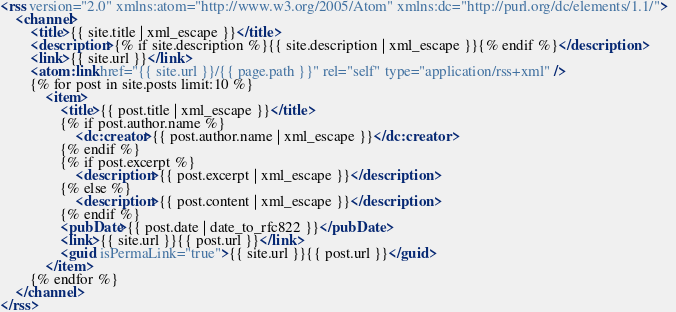Convert code to text. <code><loc_0><loc_0><loc_500><loc_500><_XML_><rss version="2.0" xmlns:atom="http://www.w3.org/2005/Atom" xmlns:dc="http://purl.org/dc/elements/1.1/">
	<channel>
		<title>{{ site.title | xml_escape }}</title>
		<description>{% if site.description %}{{ site.description | xml_escape }}{% endif %}</description>		
		<link>{{ site.url }}</link>
		<atom:link href="{{ site.url }}/{{ page.path }}" rel="self" type="application/rss+xml" />
		{% for post in site.posts limit:10 %}
			<item>
				<title>{{ post.title | xml_escape }}</title>
				{% if post.author.name %}
					<dc:creator>{{ post.author.name | xml_escape }}</dc:creator>
				{% endif %}        
				{% if post.excerpt %}
					<description>{{ post.excerpt | xml_escape }}</description>
				{% else %}
					<description>{{ post.content | xml_escape }}</description>
				{% endif %}
				<pubDate>{{ post.date | date_to_rfc822 }}</pubDate>
				<link>{{ site.url }}{{ post.url }}</link>
				<guid isPermaLink="true">{{ site.url }}{{ post.url }}</guid>
			</item>
		{% endfor %}
	</channel>
</rss></code> 